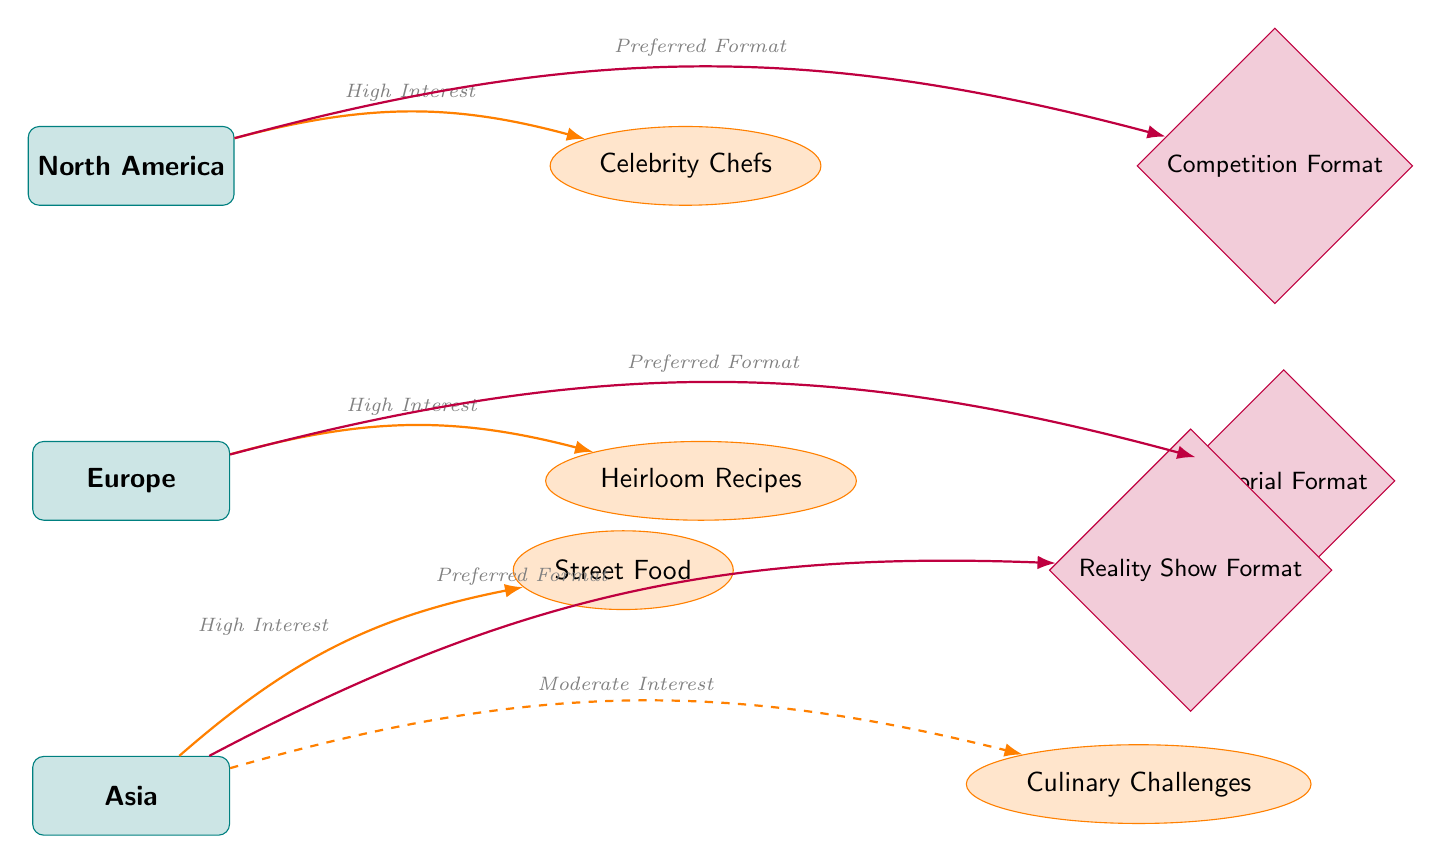What region has a high interest in celebrity chefs? The diagram indicates that North America has a "High Interest" in the theme of "Celebrity Chefs." This connection is clearly seen in the edge labeled with "High Interest" between North America and the Celebrity Chefs theme.
Answer: North America Which region is associated with heirloom recipes? According to the diagram, Europe is connected to the theme of "Heirloom Recipes" with a "High Interest" edge, indicating positive regional viewership preferences toward this theme.
Answer: Europe What is the preferred format for cooking shows in Asia? The diagram shows that Asia has a "Preferred Format" of "Reality Show Format" indicated by the edge connecting Asia to this format node.
Answer: Reality Show Format How many themes are represented in the diagram? The diagram displays three distinct theme nodes: Celebrity Chefs, Heirloom Recipes, and Street Food/Culinary Challenges. By counting these, we can determine the total number of themes represented.
Answer: Four What type of format is preferred in Europe? The edge connecting Europe to the format node indicates that the "Tutorial Format" is the preferred format for cooking shows in that region.
Answer: Tutorial Format Is there a region with moderate interest in culinary challenges? The diagram specifies that Asia shows a "Moderate Interest" in "Culinary Challenges," indicated by the dashed edge leading to this theme.
Answer: Yes What is the relationship between North America and competition format? The diagram indicates that North America has a "Preferred Format" of "Competition Format," which is directly linked by the edge from North America to this format node.
Answer: Preferred Format Which region does not show interest in culinary challenges? Culinary challenges are connected to Asia with a "Moderate Interest," and since North America and Europe are not linked to this theme, we can say that they do not show interest in culinary challenges.
Answer: North America and Europe What theme shows high interest in Asia? The diagram indicates that Asia has a "High Interest" in the theme of "Street Food," shown by the edge linking Asia to this theme.
Answer: Street Food 